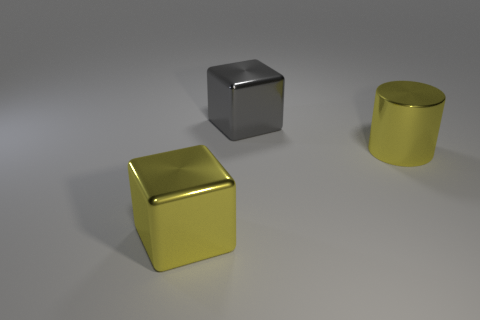How many other things are there of the same size as the gray cube?
Provide a succinct answer. 2. Is the number of big metal cubes less than the number of gray cubes?
Your answer should be compact. No. The gray object has what shape?
Your answer should be very brief. Cube. There is a big shiny thing in front of the big yellow cylinder; is its color the same as the shiny cylinder?
Your answer should be very brief. Yes. There is a large object that is both behind the yellow metallic block and in front of the big gray metal object; what shape is it?
Give a very brief answer. Cylinder. What color is the large thing to the left of the large gray metal object?
Your answer should be very brief. Yellow. Is there any other thing that is the same color as the big cylinder?
Offer a terse response. Yes. Is the size of the yellow metal cylinder the same as the gray metal object?
Offer a terse response. Yes. There is a metal object that is behind the yellow block and left of the metal cylinder; what size is it?
Give a very brief answer. Large. How many large objects have the same material as the large gray block?
Ensure brevity in your answer.  2. 